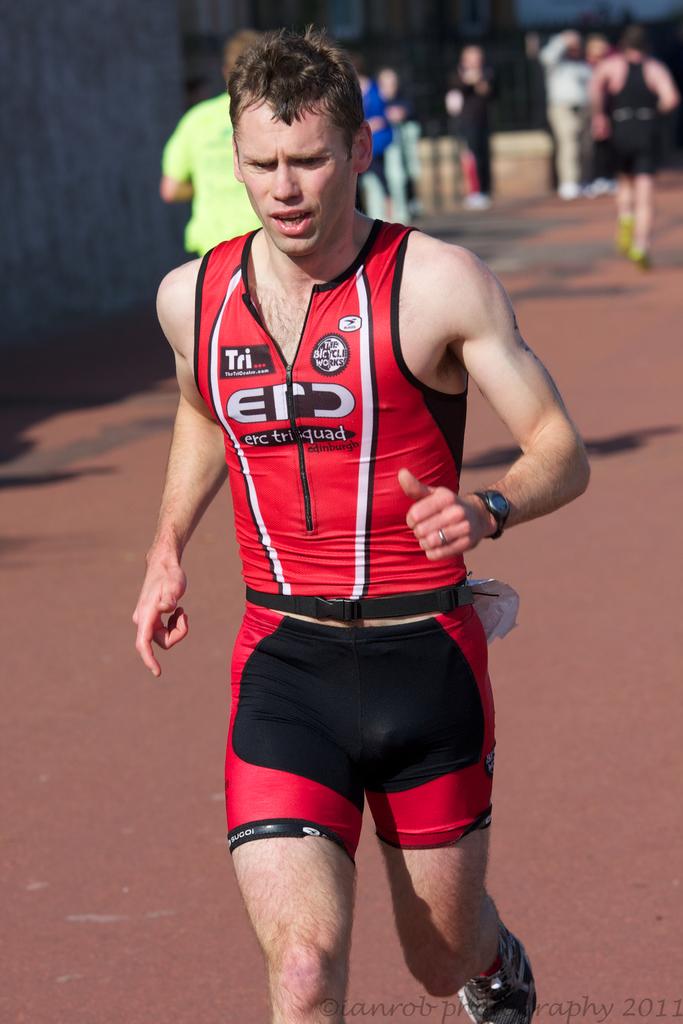What are the letters on his shirt?
Offer a very short reply. Erd. 